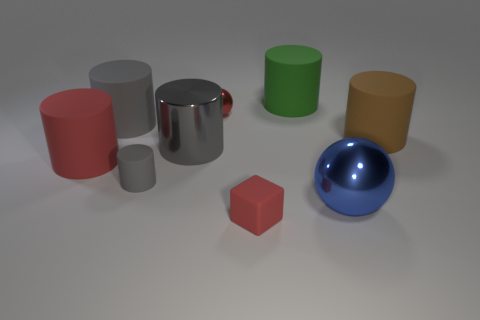How many objects are cylinders or gray shiny cylinders?
Provide a succinct answer. 6. What color is the metal object to the right of the metal sphere to the left of the small rubber thing that is in front of the big metal ball?
Provide a short and direct response. Blue. Is there any other thing that is the same color as the big metallic ball?
Ensure brevity in your answer.  No. Is the size of the gray metal cylinder the same as the rubber block?
Provide a succinct answer. No. How many things are large metallic objects that are in front of the big red rubber cylinder or small matte things to the right of the small gray matte cylinder?
Provide a short and direct response. 2. What material is the small red object that is in front of the thing that is right of the blue metallic ball?
Ensure brevity in your answer.  Rubber. How many other objects are there of the same material as the large green cylinder?
Keep it short and to the point. 5. Is the shape of the tiny gray rubber object the same as the big gray rubber object?
Make the answer very short. Yes. What is the size of the rubber object that is in front of the large ball?
Offer a terse response. Small. There is a red cylinder; does it have the same size as the metal sphere that is behind the gray metallic thing?
Provide a short and direct response. No. 